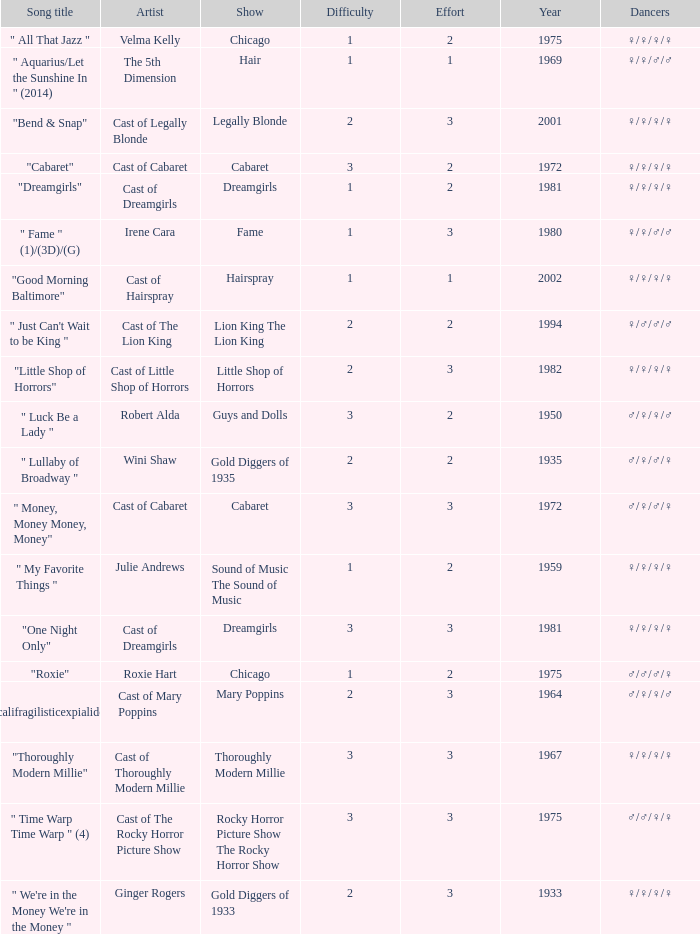How many artists were there for the show thoroughly modern millie? 1.0. 